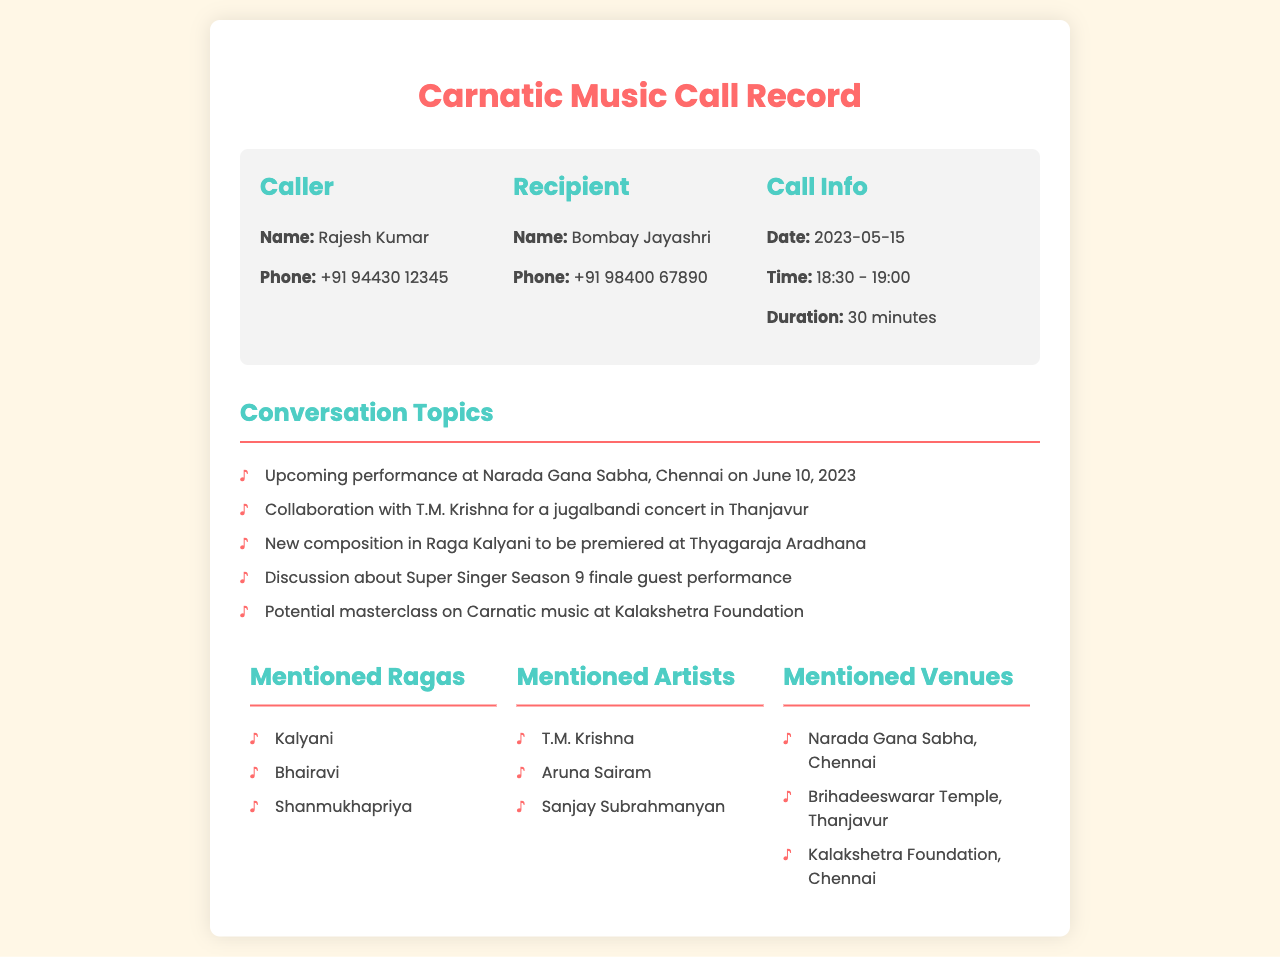What is the name of the caller? The caller's name is mentioned explicitly in the document under the "Caller" section.
Answer: Rajesh Kumar What is the phone number of the recipient? The document specifies the phone number of the recipient under the "Recipient" section.
Answer: +91 98400 67890 What is the duration of the call? The duration of the call is noted in the "Call Info" section of the document.
Answer: 30 minutes When is the upcoming performance at Narada Gana Sabha? The date of the upcoming performance is listed under the "Conversation Topics" section.
Answer: June 10, 2023 Which Ragas were mentioned during the conversation? The mentioned Ragas are listed under the "Mentioned Ragas" section, providing specific names.
Answer: Kalyani, Bhairavi, Shanmukhapriya What is planned for the Thyagaraja Aradhana? The document outlines a new composition that is set to premiere at this event in the "Conversation Topics."
Answer: New composition in Raga Kalyani Who is collaborating with Bombay Jayashri for a concert? The collaboration is detailed in the "Conversation Topics," identifying the artist.
Answer: T.M. Krishna Which venue is associated with the jugalbandi concert? The relevant venue for the concert is mentioned in the "Mentioned Venues" section.
Answer: Brihadeeswarar Temple, Thanjavur What type of class is being considered at Kalakshetra Foundation? The document mentions a potential educational offering in the "Conversation Topics" section.
Answer: Masterclass on Carnatic music 